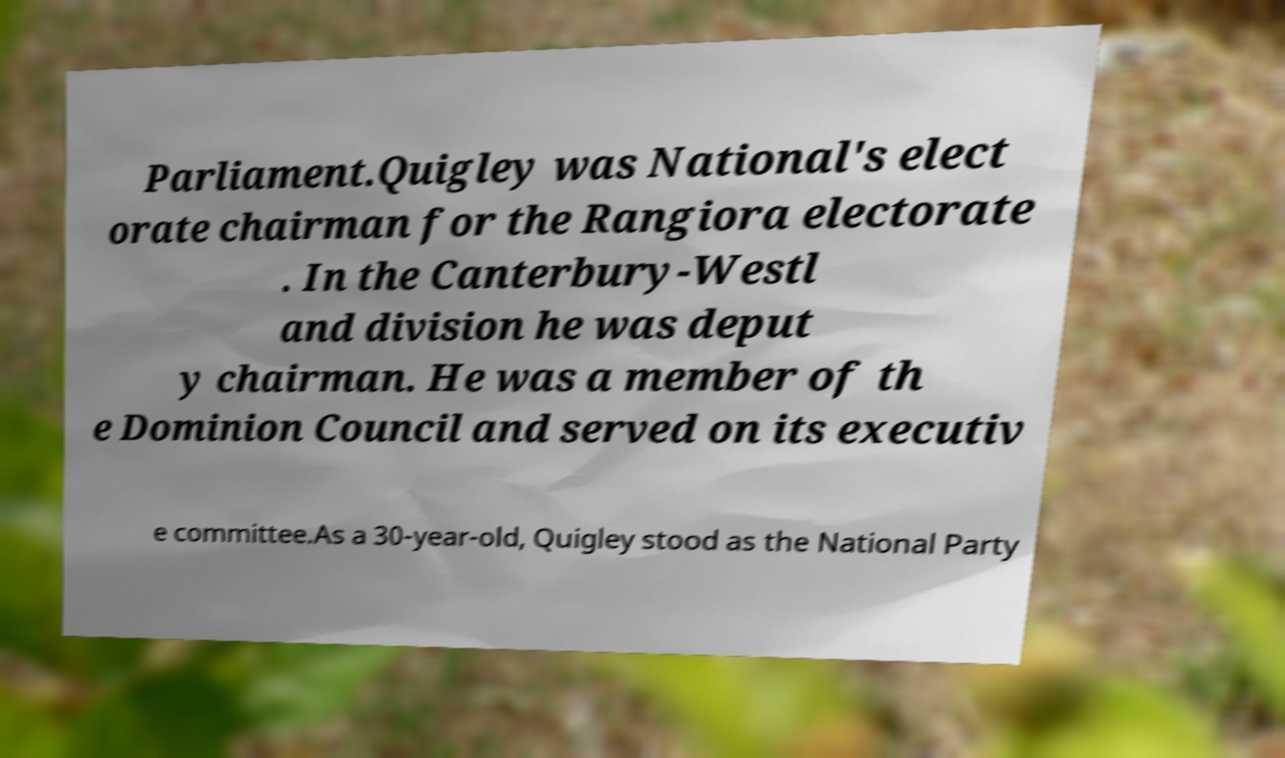There's text embedded in this image that I need extracted. Can you transcribe it verbatim? Parliament.Quigley was National's elect orate chairman for the Rangiora electorate . In the Canterbury-Westl and division he was deput y chairman. He was a member of th e Dominion Council and served on its executiv e committee.As a 30-year-old, Quigley stood as the National Party 